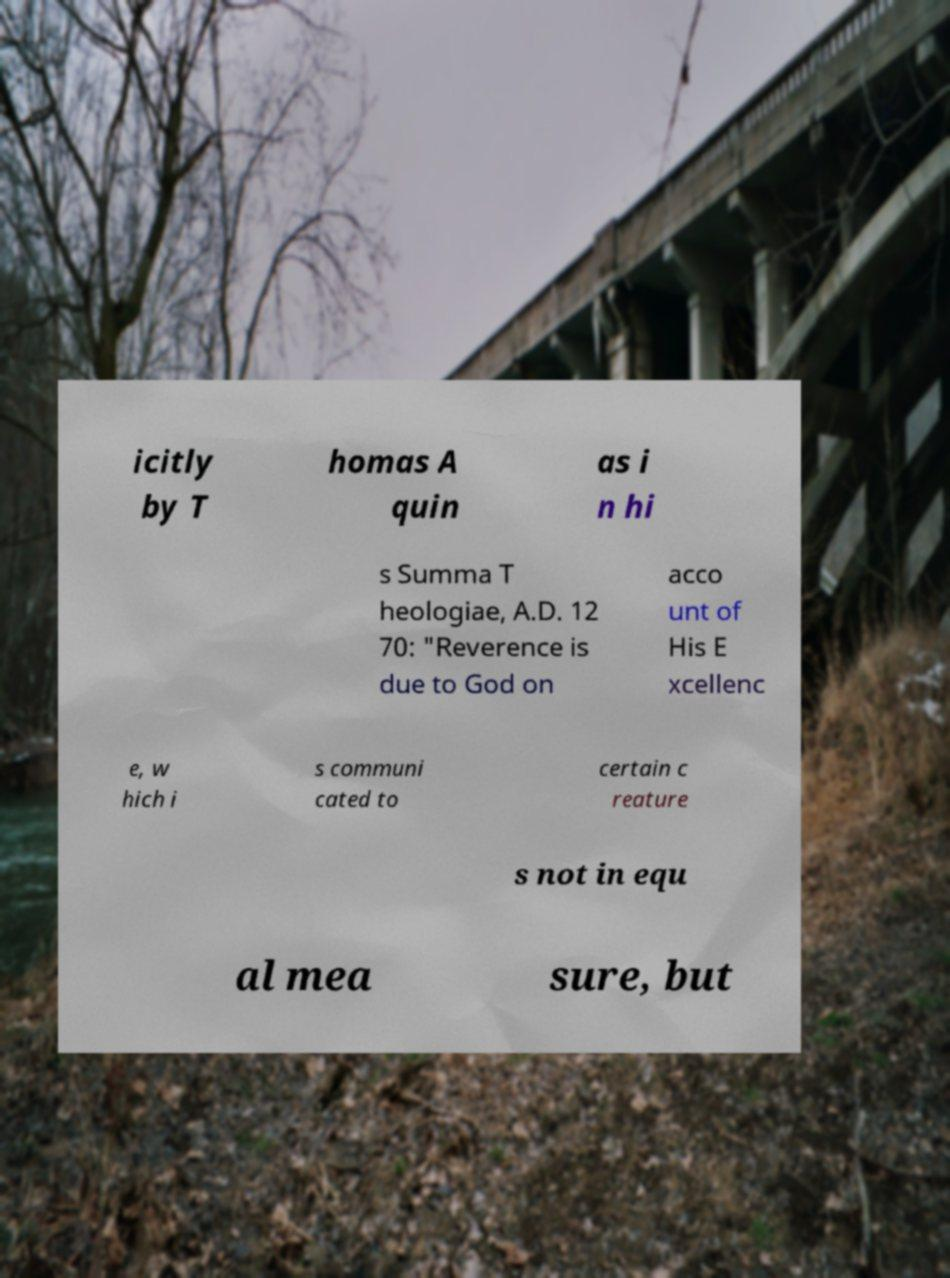What messages or text are displayed in this image? I need them in a readable, typed format. icitly by T homas A quin as i n hi s Summa T heologiae, A.D. 12 70: "Reverence is due to God on acco unt of His E xcellenc e, w hich i s communi cated to certain c reature s not in equ al mea sure, but 